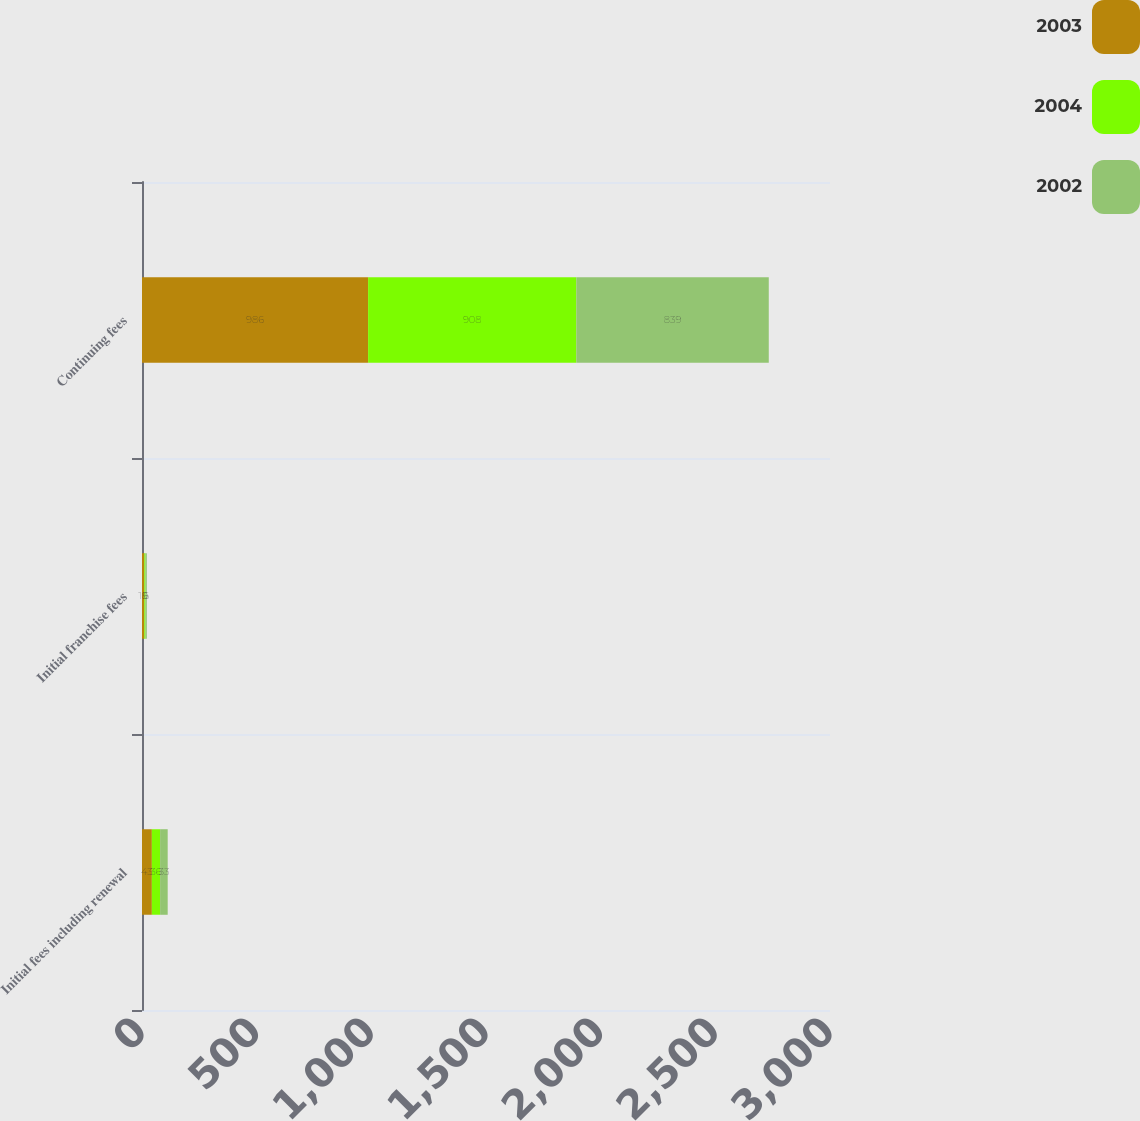Convert chart to OTSL. <chart><loc_0><loc_0><loc_500><loc_500><stacked_bar_chart><ecel><fcel>Initial fees including renewal<fcel>Initial franchise fees<fcel>Continuing fees<nl><fcel>2003<fcel>43<fcel>10<fcel>986<nl><fcel>2004<fcel>36<fcel>5<fcel>908<nl><fcel>2002<fcel>33<fcel>6<fcel>839<nl></chart> 